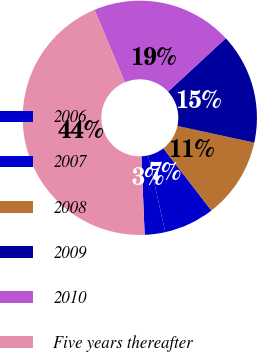<chart> <loc_0><loc_0><loc_500><loc_500><pie_chart><fcel>2006<fcel>2007<fcel>2008<fcel>2009<fcel>2010<fcel>Five years thereafter<nl><fcel>2.83%<fcel>6.98%<fcel>11.13%<fcel>15.28%<fcel>19.43%<fcel>44.33%<nl></chart> 